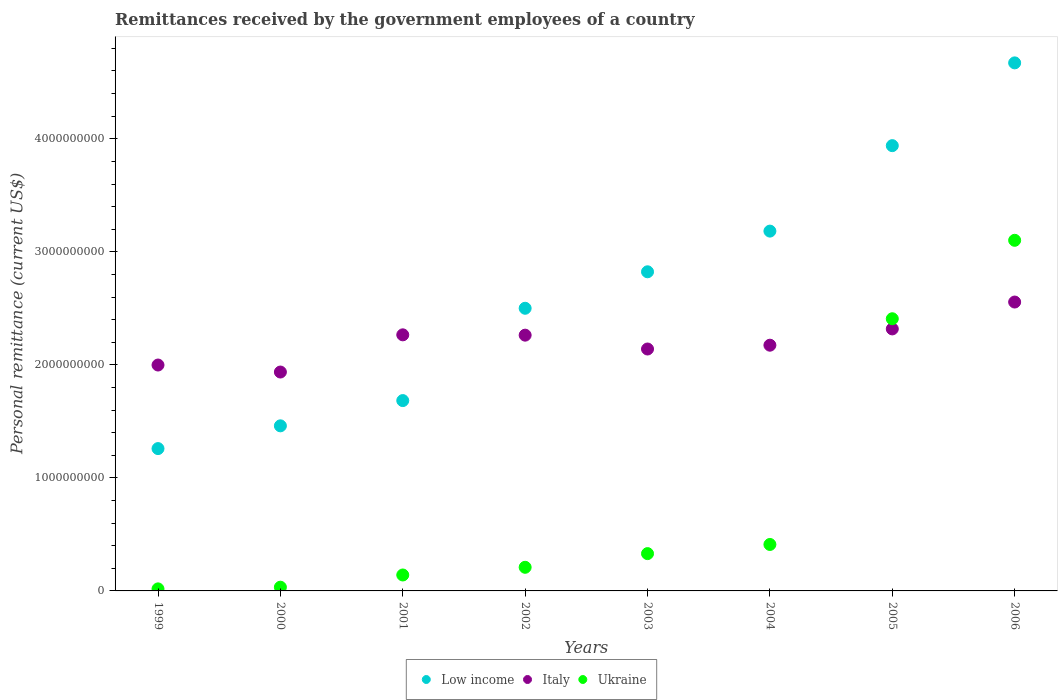How many different coloured dotlines are there?
Provide a short and direct response. 3. What is the remittances received by the government employees in Ukraine in 2006?
Keep it short and to the point. 3.10e+09. Across all years, what is the maximum remittances received by the government employees in Low income?
Give a very brief answer. 4.67e+09. Across all years, what is the minimum remittances received by the government employees in Ukraine?
Make the answer very short. 1.80e+07. In which year was the remittances received by the government employees in Italy maximum?
Keep it short and to the point. 2006. In which year was the remittances received by the government employees in Low income minimum?
Keep it short and to the point. 1999. What is the total remittances received by the government employees in Low income in the graph?
Your answer should be compact. 2.15e+1. What is the difference between the remittances received by the government employees in Low income in 2000 and that in 2001?
Provide a short and direct response. -2.23e+08. What is the difference between the remittances received by the government employees in Ukraine in 2002 and the remittances received by the government employees in Italy in 2005?
Your answer should be compact. -2.11e+09. What is the average remittances received by the government employees in Low income per year?
Offer a very short reply. 2.69e+09. In the year 2004, what is the difference between the remittances received by the government employees in Italy and remittances received by the government employees in Low income?
Your response must be concise. -1.01e+09. In how many years, is the remittances received by the government employees in Low income greater than 3800000000 US$?
Provide a short and direct response. 2. What is the ratio of the remittances received by the government employees in Italy in 1999 to that in 2003?
Your answer should be compact. 0.93. Is the remittances received by the government employees in Low income in 1999 less than that in 2006?
Make the answer very short. Yes. Is the difference between the remittances received by the government employees in Italy in 1999 and 2002 greater than the difference between the remittances received by the government employees in Low income in 1999 and 2002?
Your answer should be very brief. Yes. What is the difference between the highest and the second highest remittances received by the government employees in Italy?
Your answer should be very brief. 2.38e+08. What is the difference between the highest and the lowest remittances received by the government employees in Ukraine?
Your answer should be very brief. 3.08e+09. How many dotlines are there?
Ensure brevity in your answer.  3. Are the values on the major ticks of Y-axis written in scientific E-notation?
Your answer should be very brief. No. How are the legend labels stacked?
Keep it short and to the point. Horizontal. What is the title of the graph?
Offer a very short reply. Remittances received by the government employees of a country. Does "Montenegro" appear as one of the legend labels in the graph?
Offer a terse response. No. What is the label or title of the Y-axis?
Provide a short and direct response. Personal remittance (current US$). What is the Personal remittance (current US$) in Low income in 1999?
Give a very brief answer. 1.26e+09. What is the Personal remittance (current US$) in Italy in 1999?
Ensure brevity in your answer.  2.00e+09. What is the Personal remittance (current US$) in Ukraine in 1999?
Offer a terse response. 1.80e+07. What is the Personal remittance (current US$) in Low income in 2000?
Your answer should be very brief. 1.46e+09. What is the Personal remittance (current US$) of Italy in 2000?
Ensure brevity in your answer.  1.94e+09. What is the Personal remittance (current US$) in Ukraine in 2000?
Your answer should be very brief. 3.30e+07. What is the Personal remittance (current US$) of Low income in 2001?
Offer a very short reply. 1.68e+09. What is the Personal remittance (current US$) of Italy in 2001?
Give a very brief answer. 2.27e+09. What is the Personal remittance (current US$) of Ukraine in 2001?
Give a very brief answer. 1.41e+08. What is the Personal remittance (current US$) of Low income in 2002?
Make the answer very short. 2.50e+09. What is the Personal remittance (current US$) in Italy in 2002?
Ensure brevity in your answer.  2.26e+09. What is the Personal remittance (current US$) of Ukraine in 2002?
Keep it short and to the point. 2.09e+08. What is the Personal remittance (current US$) in Low income in 2003?
Your answer should be compact. 2.82e+09. What is the Personal remittance (current US$) in Italy in 2003?
Provide a succinct answer. 2.14e+09. What is the Personal remittance (current US$) in Ukraine in 2003?
Keep it short and to the point. 3.30e+08. What is the Personal remittance (current US$) in Low income in 2004?
Offer a very short reply. 3.18e+09. What is the Personal remittance (current US$) of Italy in 2004?
Your answer should be compact. 2.17e+09. What is the Personal remittance (current US$) of Ukraine in 2004?
Provide a short and direct response. 4.11e+08. What is the Personal remittance (current US$) of Low income in 2005?
Your answer should be very brief. 3.94e+09. What is the Personal remittance (current US$) of Italy in 2005?
Your response must be concise. 2.32e+09. What is the Personal remittance (current US$) of Ukraine in 2005?
Ensure brevity in your answer.  2.41e+09. What is the Personal remittance (current US$) of Low income in 2006?
Make the answer very short. 4.67e+09. What is the Personal remittance (current US$) of Italy in 2006?
Give a very brief answer. 2.56e+09. What is the Personal remittance (current US$) in Ukraine in 2006?
Your answer should be compact. 3.10e+09. Across all years, what is the maximum Personal remittance (current US$) in Low income?
Offer a very short reply. 4.67e+09. Across all years, what is the maximum Personal remittance (current US$) of Italy?
Make the answer very short. 2.56e+09. Across all years, what is the maximum Personal remittance (current US$) of Ukraine?
Ensure brevity in your answer.  3.10e+09. Across all years, what is the minimum Personal remittance (current US$) of Low income?
Offer a very short reply. 1.26e+09. Across all years, what is the minimum Personal remittance (current US$) in Italy?
Keep it short and to the point. 1.94e+09. Across all years, what is the minimum Personal remittance (current US$) of Ukraine?
Ensure brevity in your answer.  1.80e+07. What is the total Personal remittance (current US$) in Low income in the graph?
Keep it short and to the point. 2.15e+1. What is the total Personal remittance (current US$) in Italy in the graph?
Your response must be concise. 1.77e+1. What is the total Personal remittance (current US$) of Ukraine in the graph?
Your response must be concise. 6.65e+09. What is the difference between the Personal remittance (current US$) of Low income in 1999 and that in 2000?
Your response must be concise. -2.01e+08. What is the difference between the Personal remittance (current US$) in Italy in 1999 and that in 2000?
Ensure brevity in your answer.  6.20e+07. What is the difference between the Personal remittance (current US$) of Ukraine in 1999 and that in 2000?
Your response must be concise. -1.50e+07. What is the difference between the Personal remittance (current US$) in Low income in 1999 and that in 2001?
Provide a succinct answer. -4.25e+08. What is the difference between the Personal remittance (current US$) of Italy in 1999 and that in 2001?
Offer a terse response. -2.67e+08. What is the difference between the Personal remittance (current US$) in Ukraine in 1999 and that in 2001?
Your response must be concise. -1.23e+08. What is the difference between the Personal remittance (current US$) in Low income in 1999 and that in 2002?
Offer a terse response. -1.24e+09. What is the difference between the Personal remittance (current US$) in Italy in 1999 and that in 2002?
Make the answer very short. -2.64e+08. What is the difference between the Personal remittance (current US$) in Ukraine in 1999 and that in 2002?
Your answer should be very brief. -1.91e+08. What is the difference between the Personal remittance (current US$) in Low income in 1999 and that in 2003?
Offer a very short reply. -1.56e+09. What is the difference between the Personal remittance (current US$) in Italy in 1999 and that in 2003?
Your answer should be compact. -1.42e+08. What is the difference between the Personal remittance (current US$) in Ukraine in 1999 and that in 2003?
Offer a terse response. -3.12e+08. What is the difference between the Personal remittance (current US$) of Low income in 1999 and that in 2004?
Your answer should be compact. -1.92e+09. What is the difference between the Personal remittance (current US$) of Italy in 1999 and that in 2004?
Keep it short and to the point. -1.75e+08. What is the difference between the Personal remittance (current US$) of Ukraine in 1999 and that in 2004?
Provide a short and direct response. -3.93e+08. What is the difference between the Personal remittance (current US$) in Low income in 1999 and that in 2005?
Keep it short and to the point. -2.68e+09. What is the difference between the Personal remittance (current US$) in Italy in 1999 and that in 2005?
Make the answer very short. -3.20e+08. What is the difference between the Personal remittance (current US$) of Ukraine in 1999 and that in 2005?
Provide a short and direct response. -2.39e+09. What is the difference between the Personal remittance (current US$) of Low income in 1999 and that in 2006?
Ensure brevity in your answer.  -3.41e+09. What is the difference between the Personal remittance (current US$) in Italy in 1999 and that in 2006?
Provide a short and direct response. -5.57e+08. What is the difference between the Personal remittance (current US$) of Ukraine in 1999 and that in 2006?
Provide a short and direct response. -3.08e+09. What is the difference between the Personal remittance (current US$) of Low income in 2000 and that in 2001?
Your answer should be very brief. -2.23e+08. What is the difference between the Personal remittance (current US$) in Italy in 2000 and that in 2001?
Your response must be concise. -3.29e+08. What is the difference between the Personal remittance (current US$) in Ukraine in 2000 and that in 2001?
Offer a terse response. -1.08e+08. What is the difference between the Personal remittance (current US$) of Low income in 2000 and that in 2002?
Your response must be concise. -1.04e+09. What is the difference between the Personal remittance (current US$) in Italy in 2000 and that in 2002?
Your response must be concise. -3.26e+08. What is the difference between the Personal remittance (current US$) of Ukraine in 2000 and that in 2002?
Provide a short and direct response. -1.76e+08. What is the difference between the Personal remittance (current US$) in Low income in 2000 and that in 2003?
Keep it short and to the point. -1.36e+09. What is the difference between the Personal remittance (current US$) of Italy in 2000 and that in 2003?
Make the answer very short. -2.04e+08. What is the difference between the Personal remittance (current US$) of Ukraine in 2000 and that in 2003?
Keep it short and to the point. -2.97e+08. What is the difference between the Personal remittance (current US$) in Low income in 2000 and that in 2004?
Offer a terse response. -1.72e+09. What is the difference between the Personal remittance (current US$) of Italy in 2000 and that in 2004?
Your answer should be compact. -2.37e+08. What is the difference between the Personal remittance (current US$) in Ukraine in 2000 and that in 2004?
Keep it short and to the point. -3.78e+08. What is the difference between the Personal remittance (current US$) in Low income in 2000 and that in 2005?
Ensure brevity in your answer.  -2.48e+09. What is the difference between the Personal remittance (current US$) of Italy in 2000 and that in 2005?
Your response must be concise. -3.82e+08. What is the difference between the Personal remittance (current US$) in Ukraine in 2000 and that in 2005?
Your answer should be compact. -2.38e+09. What is the difference between the Personal remittance (current US$) of Low income in 2000 and that in 2006?
Keep it short and to the point. -3.21e+09. What is the difference between the Personal remittance (current US$) in Italy in 2000 and that in 2006?
Make the answer very short. -6.19e+08. What is the difference between the Personal remittance (current US$) of Ukraine in 2000 and that in 2006?
Offer a terse response. -3.07e+09. What is the difference between the Personal remittance (current US$) of Low income in 2001 and that in 2002?
Provide a succinct answer. -8.17e+08. What is the difference between the Personal remittance (current US$) in Italy in 2001 and that in 2002?
Give a very brief answer. 2.88e+06. What is the difference between the Personal remittance (current US$) of Ukraine in 2001 and that in 2002?
Your answer should be compact. -6.80e+07. What is the difference between the Personal remittance (current US$) in Low income in 2001 and that in 2003?
Offer a terse response. -1.14e+09. What is the difference between the Personal remittance (current US$) in Italy in 2001 and that in 2003?
Give a very brief answer. 1.25e+08. What is the difference between the Personal remittance (current US$) of Ukraine in 2001 and that in 2003?
Ensure brevity in your answer.  -1.89e+08. What is the difference between the Personal remittance (current US$) in Low income in 2001 and that in 2004?
Your answer should be compact. -1.50e+09. What is the difference between the Personal remittance (current US$) in Italy in 2001 and that in 2004?
Your response must be concise. 9.17e+07. What is the difference between the Personal remittance (current US$) of Ukraine in 2001 and that in 2004?
Give a very brief answer. -2.70e+08. What is the difference between the Personal remittance (current US$) in Low income in 2001 and that in 2005?
Make the answer very short. -2.26e+09. What is the difference between the Personal remittance (current US$) of Italy in 2001 and that in 2005?
Your answer should be compact. -5.24e+07. What is the difference between the Personal remittance (current US$) in Ukraine in 2001 and that in 2005?
Offer a very short reply. -2.27e+09. What is the difference between the Personal remittance (current US$) of Low income in 2001 and that in 2006?
Ensure brevity in your answer.  -2.99e+09. What is the difference between the Personal remittance (current US$) of Italy in 2001 and that in 2006?
Your response must be concise. -2.90e+08. What is the difference between the Personal remittance (current US$) of Ukraine in 2001 and that in 2006?
Your answer should be compact. -2.96e+09. What is the difference between the Personal remittance (current US$) of Low income in 2002 and that in 2003?
Offer a very short reply. -3.23e+08. What is the difference between the Personal remittance (current US$) in Italy in 2002 and that in 2003?
Your response must be concise. 1.23e+08. What is the difference between the Personal remittance (current US$) in Ukraine in 2002 and that in 2003?
Your answer should be very brief. -1.21e+08. What is the difference between the Personal remittance (current US$) in Low income in 2002 and that in 2004?
Offer a very short reply. -6.83e+08. What is the difference between the Personal remittance (current US$) in Italy in 2002 and that in 2004?
Make the answer very short. 8.88e+07. What is the difference between the Personal remittance (current US$) in Ukraine in 2002 and that in 2004?
Make the answer very short. -2.02e+08. What is the difference between the Personal remittance (current US$) of Low income in 2002 and that in 2005?
Your answer should be compact. -1.44e+09. What is the difference between the Personal remittance (current US$) of Italy in 2002 and that in 2005?
Ensure brevity in your answer.  -5.53e+07. What is the difference between the Personal remittance (current US$) of Ukraine in 2002 and that in 2005?
Keep it short and to the point. -2.20e+09. What is the difference between the Personal remittance (current US$) in Low income in 2002 and that in 2006?
Your answer should be compact. -2.17e+09. What is the difference between the Personal remittance (current US$) of Italy in 2002 and that in 2006?
Make the answer very short. -2.93e+08. What is the difference between the Personal remittance (current US$) of Ukraine in 2002 and that in 2006?
Your answer should be very brief. -2.89e+09. What is the difference between the Personal remittance (current US$) in Low income in 2003 and that in 2004?
Make the answer very short. -3.60e+08. What is the difference between the Personal remittance (current US$) in Italy in 2003 and that in 2004?
Your answer should be compact. -3.37e+07. What is the difference between the Personal remittance (current US$) of Ukraine in 2003 and that in 2004?
Ensure brevity in your answer.  -8.10e+07. What is the difference between the Personal remittance (current US$) of Low income in 2003 and that in 2005?
Provide a short and direct response. -1.12e+09. What is the difference between the Personal remittance (current US$) in Italy in 2003 and that in 2005?
Your answer should be compact. -1.78e+08. What is the difference between the Personal remittance (current US$) of Ukraine in 2003 and that in 2005?
Your response must be concise. -2.08e+09. What is the difference between the Personal remittance (current US$) in Low income in 2003 and that in 2006?
Ensure brevity in your answer.  -1.85e+09. What is the difference between the Personal remittance (current US$) of Italy in 2003 and that in 2006?
Keep it short and to the point. -4.16e+08. What is the difference between the Personal remittance (current US$) in Ukraine in 2003 and that in 2006?
Your answer should be compact. -2.77e+09. What is the difference between the Personal remittance (current US$) in Low income in 2004 and that in 2005?
Ensure brevity in your answer.  -7.56e+08. What is the difference between the Personal remittance (current US$) of Italy in 2004 and that in 2005?
Ensure brevity in your answer.  -1.44e+08. What is the difference between the Personal remittance (current US$) in Ukraine in 2004 and that in 2005?
Offer a very short reply. -2.00e+09. What is the difference between the Personal remittance (current US$) of Low income in 2004 and that in 2006?
Your response must be concise. -1.49e+09. What is the difference between the Personal remittance (current US$) in Italy in 2004 and that in 2006?
Provide a short and direct response. -3.82e+08. What is the difference between the Personal remittance (current US$) of Ukraine in 2004 and that in 2006?
Your response must be concise. -2.69e+09. What is the difference between the Personal remittance (current US$) in Low income in 2005 and that in 2006?
Offer a very short reply. -7.32e+08. What is the difference between the Personal remittance (current US$) of Italy in 2005 and that in 2006?
Your answer should be very brief. -2.38e+08. What is the difference between the Personal remittance (current US$) of Ukraine in 2005 and that in 2006?
Provide a succinct answer. -6.94e+08. What is the difference between the Personal remittance (current US$) in Low income in 1999 and the Personal remittance (current US$) in Italy in 2000?
Provide a short and direct response. -6.77e+08. What is the difference between the Personal remittance (current US$) in Low income in 1999 and the Personal remittance (current US$) in Ukraine in 2000?
Offer a very short reply. 1.23e+09. What is the difference between the Personal remittance (current US$) of Italy in 1999 and the Personal remittance (current US$) of Ukraine in 2000?
Your response must be concise. 1.97e+09. What is the difference between the Personal remittance (current US$) in Low income in 1999 and the Personal remittance (current US$) in Italy in 2001?
Your answer should be compact. -1.01e+09. What is the difference between the Personal remittance (current US$) of Low income in 1999 and the Personal remittance (current US$) of Ukraine in 2001?
Offer a terse response. 1.12e+09. What is the difference between the Personal remittance (current US$) in Italy in 1999 and the Personal remittance (current US$) in Ukraine in 2001?
Your answer should be very brief. 1.86e+09. What is the difference between the Personal remittance (current US$) of Low income in 1999 and the Personal remittance (current US$) of Italy in 2002?
Keep it short and to the point. -1.00e+09. What is the difference between the Personal remittance (current US$) in Low income in 1999 and the Personal remittance (current US$) in Ukraine in 2002?
Your answer should be compact. 1.05e+09. What is the difference between the Personal remittance (current US$) in Italy in 1999 and the Personal remittance (current US$) in Ukraine in 2002?
Give a very brief answer. 1.79e+09. What is the difference between the Personal remittance (current US$) of Low income in 1999 and the Personal remittance (current US$) of Italy in 2003?
Your response must be concise. -8.81e+08. What is the difference between the Personal remittance (current US$) in Low income in 1999 and the Personal remittance (current US$) in Ukraine in 2003?
Keep it short and to the point. 9.29e+08. What is the difference between the Personal remittance (current US$) of Italy in 1999 and the Personal remittance (current US$) of Ukraine in 2003?
Offer a terse response. 1.67e+09. What is the difference between the Personal remittance (current US$) in Low income in 1999 and the Personal remittance (current US$) in Italy in 2004?
Give a very brief answer. -9.15e+08. What is the difference between the Personal remittance (current US$) of Low income in 1999 and the Personal remittance (current US$) of Ukraine in 2004?
Your answer should be compact. 8.48e+08. What is the difference between the Personal remittance (current US$) in Italy in 1999 and the Personal remittance (current US$) in Ukraine in 2004?
Your answer should be very brief. 1.59e+09. What is the difference between the Personal remittance (current US$) of Low income in 1999 and the Personal remittance (current US$) of Italy in 2005?
Offer a terse response. -1.06e+09. What is the difference between the Personal remittance (current US$) in Low income in 1999 and the Personal remittance (current US$) in Ukraine in 2005?
Your response must be concise. -1.15e+09. What is the difference between the Personal remittance (current US$) in Italy in 1999 and the Personal remittance (current US$) in Ukraine in 2005?
Make the answer very short. -4.09e+08. What is the difference between the Personal remittance (current US$) of Low income in 1999 and the Personal remittance (current US$) of Italy in 2006?
Keep it short and to the point. -1.30e+09. What is the difference between the Personal remittance (current US$) of Low income in 1999 and the Personal remittance (current US$) of Ukraine in 2006?
Make the answer very short. -1.84e+09. What is the difference between the Personal remittance (current US$) of Italy in 1999 and the Personal remittance (current US$) of Ukraine in 2006?
Your response must be concise. -1.10e+09. What is the difference between the Personal remittance (current US$) in Low income in 2000 and the Personal remittance (current US$) in Italy in 2001?
Provide a short and direct response. -8.05e+08. What is the difference between the Personal remittance (current US$) of Low income in 2000 and the Personal remittance (current US$) of Ukraine in 2001?
Make the answer very short. 1.32e+09. What is the difference between the Personal remittance (current US$) in Italy in 2000 and the Personal remittance (current US$) in Ukraine in 2001?
Your answer should be very brief. 1.80e+09. What is the difference between the Personal remittance (current US$) of Low income in 2000 and the Personal remittance (current US$) of Italy in 2002?
Offer a terse response. -8.02e+08. What is the difference between the Personal remittance (current US$) of Low income in 2000 and the Personal remittance (current US$) of Ukraine in 2002?
Your answer should be very brief. 1.25e+09. What is the difference between the Personal remittance (current US$) of Italy in 2000 and the Personal remittance (current US$) of Ukraine in 2002?
Provide a short and direct response. 1.73e+09. What is the difference between the Personal remittance (current US$) in Low income in 2000 and the Personal remittance (current US$) in Italy in 2003?
Offer a very short reply. -6.80e+08. What is the difference between the Personal remittance (current US$) of Low income in 2000 and the Personal remittance (current US$) of Ukraine in 2003?
Your answer should be compact. 1.13e+09. What is the difference between the Personal remittance (current US$) of Italy in 2000 and the Personal remittance (current US$) of Ukraine in 2003?
Provide a short and direct response. 1.61e+09. What is the difference between the Personal remittance (current US$) in Low income in 2000 and the Personal remittance (current US$) in Italy in 2004?
Offer a terse response. -7.13e+08. What is the difference between the Personal remittance (current US$) in Low income in 2000 and the Personal remittance (current US$) in Ukraine in 2004?
Your answer should be compact. 1.05e+09. What is the difference between the Personal remittance (current US$) in Italy in 2000 and the Personal remittance (current US$) in Ukraine in 2004?
Your answer should be compact. 1.53e+09. What is the difference between the Personal remittance (current US$) in Low income in 2000 and the Personal remittance (current US$) in Italy in 2005?
Your answer should be compact. -8.58e+08. What is the difference between the Personal remittance (current US$) in Low income in 2000 and the Personal remittance (current US$) in Ukraine in 2005?
Offer a terse response. -9.47e+08. What is the difference between the Personal remittance (current US$) of Italy in 2000 and the Personal remittance (current US$) of Ukraine in 2005?
Ensure brevity in your answer.  -4.71e+08. What is the difference between the Personal remittance (current US$) in Low income in 2000 and the Personal remittance (current US$) in Italy in 2006?
Offer a terse response. -1.10e+09. What is the difference between the Personal remittance (current US$) of Low income in 2000 and the Personal remittance (current US$) of Ukraine in 2006?
Your answer should be compact. -1.64e+09. What is the difference between the Personal remittance (current US$) in Italy in 2000 and the Personal remittance (current US$) in Ukraine in 2006?
Make the answer very short. -1.17e+09. What is the difference between the Personal remittance (current US$) in Low income in 2001 and the Personal remittance (current US$) in Italy in 2002?
Provide a succinct answer. -5.79e+08. What is the difference between the Personal remittance (current US$) in Low income in 2001 and the Personal remittance (current US$) in Ukraine in 2002?
Your answer should be compact. 1.47e+09. What is the difference between the Personal remittance (current US$) in Italy in 2001 and the Personal remittance (current US$) in Ukraine in 2002?
Make the answer very short. 2.06e+09. What is the difference between the Personal remittance (current US$) of Low income in 2001 and the Personal remittance (current US$) of Italy in 2003?
Offer a terse response. -4.56e+08. What is the difference between the Personal remittance (current US$) in Low income in 2001 and the Personal remittance (current US$) in Ukraine in 2003?
Offer a terse response. 1.35e+09. What is the difference between the Personal remittance (current US$) in Italy in 2001 and the Personal remittance (current US$) in Ukraine in 2003?
Provide a succinct answer. 1.94e+09. What is the difference between the Personal remittance (current US$) of Low income in 2001 and the Personal remittance (current US$) of Italy in 2004?
Ensure brevity in your answer.  -4.90e+08. What is the difference between the Personal remittance (current US$) in Low income in 2001 and the Personal remittance (current US$) in Ukraine in 2004?
Make the answer very short. 1.27e+09. What is the difference between the Personal remittance (current US$) in Italy in 2001 and the Personal remittance (current US$) in Ukraine in 2004?
Your answer should be very brief. 1.85e+09. What is the difference between the Personal remittance (current US$) in Low income in 2001 and the Personal remittance (current US$) in Italy in 2005?
Offer a terse response. -6.34e+08. What is the difference between the Personal remittance (current US$) in Low income in 2001 and the Personal remittance (current US$) in Ukraine in 2005?
Make the answer very short. -7.24e+08. What is the difference between the Personal remittance (current US$) of Italy in 2001 and the Personal remittance (current US$) of Ukraine in 2005?
Provide a short and direct response. -1.42e+08. What is the difference between the Personal remittance (current US$) of Low income in 2001 and the Personal remittance (current US$) of Italy in 2006?
Provide a succinct answer. -8.72e+08. What is the difference between the Personal remittance (current US$) in Low income in 2001 and the Personal remittance (current US$) in Ukraine in 2006?
Keep it short and to the point. -1.42e+09. What is the difference between the Personal remittance (current US$) in Italy in 2001 and the Personal remittance (current US$) in Ukraine in 2006?
Offer a terse response. -8.36e+08. What is the difference between the Personal remittance (current US$) of Low income in 2002 and the Personal remittance (current US$) of Italy in 2003?
Your response must be concise. 3.60e+08. What is the difference between the Personal remittance (current US$) in Low income in 2002 and the Personal remittance (current US$) in Ukraine in 2003?
Provide a succinct answer. 2.17e+09. What is the difference between the Personal remittance (current US$) in Italy in 2002 and the Personal remittance (current US$) in Ukraine in 2003?
Provide a succinct answer. 1.93e+09. What is the difference between the Personal remittance (current US$) in Low income in 2002 and the Personal remittance (current US$) in Italy in 2004?
Your answer should be compact. 3.27e+08. What is the difference between the Personal remittance (current US$) of Low income in 2002 and the Personal remittance (current US$) of Ukraine in 2004?
Your response must be concise. 2.09e+09. What is the difference between the Personal remittance (current US$) of Italy in 2002 and the Personal remittance (current US$) of Ukraine in 2004?
Keep it short and to the point. 1.85e+09. What is the difference between the Personal remittance (current US$) in Low income in 2002 and the Personal remittance (current US$) in Italy in 2005?
Your response must be concise. 1.83e+08. What is the difference between the Personal remittance (current US$) in Low income in 2002 and the Personal remittance (current US$) in Ukraine in 2005?
Ensure brevity in your answer.  9.27e+07. What is the difference between the Personal remittance (current US$) in Italy in 2002 and the Personal remittance (current US$) in Ukraine in 2005?
Your answer should be compact. -1.45e+08. What is the difference between the Personal remittance (current US$) in Low income in 2002 and the Personal remittance (current US$) in Italy in 2006?
Make the answer very short. -5.51e+07. What is the difference between the Personal remittance (current US$) in Low income in 2002 and the Personal remittance (current US$) in Ukraine in 2006?
Offer a very short reply. -6.01e+08. What is the difference between the Personal remittance (current US$) of Italy in 2002 and the Personal remittance (current US$) of Ukraine in 2006?
Your answer should be very brief. -8.39e+08. What is the difference between the Personal remittance (current US$) of Low income in 2003 and the Personal remittance (current US$) of Italy in 2004?
Provide a short and direct response. 6.49e+08. What is the difference between the Personal remittance (current US$) of Low income in 2003 and the Personal remittance (current US$) of Ukraine in 2004?
Give a very brief answer. 2.41e+09. What is the difference between the Personal remittance (current US$) of Italy in 2003 and the Personal remittance (current US$) of Ukraine in 2004?
Offer a very short reply. 1.73e+09. What is the difference between the Personal remittance (current US$) in Low income in 2003 and the Personal remittance (current US$) in Italy in 2005?
Provide a short and direct response. 5.05e+08. What is the difference between the Personal remittance (current US$) of Low income in 2003 and the Personal remittance (current US$) of Ukraine in 2005?
Your answer should be compact. 4.15e+08. What is the difference between the Personal remittance (current US$) in Italy in 2003 and the Personal remittance (current US$) in Ukraine in 2005?
Offer a very short reply. -2.68e+08. What is the difference between the Personal remittance (current US$) in Low income in 2003 and the Personal remittance (current US$) in Italy in 2006?
Ensure brevity in your answer.  2.68e+08. What is the difference between the Personal remittance (current US$) of Low income in 2003 and the Personal remittance (current US$) of Ukraine in 2006?
Your response must be concise. -2.79e+08. What is the difference between the Personal remittance (current US$) of Italy in 2003 and the Personal remittance (current US$) of Ukraine in 2006?
Provide a succinct answer. -9.62e+08. What is the difference between the Personal remittance (current US$) in Low income in 2004 and the Personal remittance (current US$) in Italy in 2005?
Your response must be concise. 8.65e+08. What is the difference between the Personal remittance (current US$) of Low income in 2004 and the Personal remittance (current US$) of Ukraine in 2005?
Your answer should be very brief. 7.75e+08. What is the difference between the Personal remittance (current US$) of Italy in 2004 and the Personal remittance (current US$) of Ukraine in 2005?
Your answer should be very brief. -2.34e+08. What is the difference between the Personal remittance (current US$) of Low income in 2004 and the Personal remittance (current US$) of Italy in 2006?
Ensure brevity in your answer.  6.28e+08. What is the difference between the Personal remittance (current US$) of Low income in 2004 and the Personal remittance (current US$) of Ukraine in 2006?
Offer a very short reply. 8.14e+07. What is the difference between the Personal remittance (current US$) in Italy in 2004 and the Personal remittance (current US$) in Ukraine in 2006?
Keep it short and to the point. -9.28e+08. What is the difference between the Personal remittance (current US$) of Low income in 2005 and the Personal remittance (current US$) of Italy in 2006?
Your answer should be compact. 1.38e+09. What is the difference between the Personal remittance (current US$) of Low income in 2005 and the Personal remittance (current US$) of Ukraine in 2006?
Your response must be concise. 8.37e+08. What is the difference between the Personal remittance (current US$) in Italy in 2005 and the Personal remittance (current US$) in Ukraine in 2006?
Give a very brief answer. -7.84e+08. What is the average Personal remittance (current US$) of Low income per year?
Your answer should be very brief. 2.69e+09. What is the average Personal remittance (current US$) in Italy per year?
Keep it short and to the point. 2.21e+09. What is the average Personal remittance (current US$) of Ukraine per year?
Give a very brief answer. 8.32e+08. In the year 1999, what is the difference between the Personal remittance (current US$) in Low income and Personal remittance (current US$) in Italy?
Ensure brevity in your answer.  -7.39e+08. In the year 1999, what is the difference between the Personal remittance (current US$) in Low income and Personal remittance (current US$) in Ukraine?
Offer a very short reply. 1.24e+09. In the year 1999, what is the difference between the Personal remittance (current US$) in Italy and Personal remittance (current US$) in Ukraine?
Provide a short and direct response. 1.98e+09. In the year 2000, what is the difference between the Personal remittance (current US$) in Low income and Personal remittance (current US$) in Italy?
Your answer should be compact. -4.76e+08. In the year 2000, what is the difference between the Personal remittance (current US$) of Low income and Personal remittance (current US$) of Ukraine?
Your answer should be compact. 1.43e+09. In the year 2000, what is the difference between the Personal remittance (current US$) in Italy and Personal remittance (current US$) in Ukraine?
Provide a short and direct response. 1.90e+09. In the year 2001, what is the difference between the Personal remittance (current US$) of Low income and Personal remittance (current US$) of Italy?
Provide a short and direct response. -5.82e+08. In the year 2001, what is the difference between the Personal remittance (current US$) of Low income and Personal remittance (current US$) of Ukraine?
Your response must be concise. 1.54e+09. In the year 2001, what is the difference between the Personal remittance (current US$) in Italy and Personal remittance (current US$) in Ukraine?
Your answer should be very brief. 2.12e+09. In the year 2002, what is the difference between the Personal remittance (current US$) of Low income and Personal remittance (current US$) of Italy?
Ensure brevity in your answer.  2.38e+08. In the year 2002, what is the difference between the Personal remittance (current US$) in Low income and Personal remittance (current US$) in Ukraine?
Keep it short and to the point. 2.29e+09. In the year 2002, what is the difference between the Personal remittance (current US$) in Italy and Personal remittance (current US$) in Ukraine?
Give a very brief answer. 2.05e+09. In the year 2003, what is the difference between the Personal remittance (current US$) in Low income and Personal remittance (current US$) in Italy?
Your answer should be compact. 6.83e+08. In the year 2003, what is the difference between the Personal remittance (current US$) in Low income and Personal remittance (current US$) in Ukraine?
Ensure brevity in your answer.  2.49e+09. In the year 2003, what is the difference between the Personal remittance (current US$) of Italy and Personal remittance (current US$) of Ukraine?
Your answer should be compact. 1.81e+09. In the year 2004, what is the difference between the Personal remittance (current US$) of Low income and Personal remittance (current US$) of Italy?
Ensure brevity in your answer.  1.01e+09. In the year 2004, what is the difference between the Personal remittance (current US$) of Low income and Personal remittance (current US$) of Ukraine?
Offer a very short reply. 2.77e+09. In the year 2004, what is the difference between the Personal remittance (current US$) in Italy and Personal remittance (current US$) in Ukraine?
Offer a very short reply. 1.76e+09. In the year 2005, what is the difference between the Personal remittance (current US$) in Low income and Personal remittance (current US$) in Italy?
Offer a very short reply. 1.62e+09. In the year 2005, what is the difference between the Personal remittance (current US$) in Low income and Personal remittance (current US$) in Ukraine?
Provide a succinct answer. 1.53e+09. In the year 2005, what is the difference between the Personal remittance (current US$) of Italy and Personal remittance (current US$) of Ukraine?
Your answer should be very brief. -8.99e+07. In the year 2006, what is the difference between the Personal remittance (current US$) in Low income and Personal remittance (current US$) in Italy?
Offer a terse response. 2.12e+09. In the year 2006, what is the difference between the Personal remittance (current US$) in Low income and Personal remittance (current US$) in Ukraine?
Ensure brevity in your answer.  1.57e+09. In the year 2006, what is the difference between the Personal remittance (current US$) in Italy and Personal remittance (current US$) in Ukraine?
Make the answer very short. -5.46e+08. What is the ratio of the Personal remittance (current US$) in Low income in 1999 to that in 2000?
Keep it short and to the point. 0.86. What is the ratio of the Personal remittance (current US$) of Italy in 1999 to that in 2000?
Provide a short and direct response. 1.03. What is the ratio of the Personal remittance (current US$) in Ukraine in 1999 to that in 2000?
Your answer should be compact. 0.55. What is the ratio of the Personal remittance (current US$) in Low income in 1999 to that in 2001?
Your answer should be very brief. 0.75. What is the ratio of the Personal remittance (current US$) in Italy in 1999 to that in 2001?
Your answer should be compact. 0.88. What is the ratio of the Personal remittance (current US$) in Ukraine in 1999 to that in 2001?
Offer a terse response. 0.13. What is the ratio of the Personal remittance (current US$) of Low income in 1999 to that in 2002?
Provide a short and direct response. 0.5. What is the ratio of the Personal remittance (current US$) in Italy in 1999 to that in 2002?
Ensure brevity in your answer.  0.88. What is the ratio of the Personal remittance (current US$) of Ukraine in 1999 to that in 2002?
Offer a terse response. 0.09. What is the ratio of the Personal remittance (current US$) of Low income in 1999 to that in 2003?
Your answer should be compact. 0.45. What is the ratio of the Personal remittance (current US$) in Italy in 1999 to that in 2003?
Keep it short and to the point. 0.93. What is the ratio of the Personal remittance (current US$) of Ukraine in 1999 to that in 2003?
Provide a succinct answer. 0.05. What is the ratio of the Personal remittance (current US$) of Low income in 1999 to that in 2004?
Keep it short and to the point. 0.4. What is the ratio of the Personal remittance (current US$) in Italy in 1999 to that in 2004?
Your answer should be compact. 0.92. What is the ratio of the Personal remittance (current US$) of Ukraine in 1999 to that in 2004?
Offer a very short reply. 0.04. What is the ratio of the Personal remittance (current US$) in Low income in 1999 to that in 2005?
Keep it short and to the point. 0.32. What is the ratio of the Personal remittance (current US$) in Italy in 1999 to that in 2005?
Ensure brevity in your answer.  0.86. What is the ratio of the Personal remittance (current US$) in Ukraine in 1999 to that in 2005?
Your answer should be very brief. 0.01. What is the ratio of the Personal remittance (current US$) in Low income in 1999 to that in 2006?
Offer a terse response. 0.27. What is the ratio of the Personal remittance (current US$) in Italy in 1999 to that in 2006?
Make the answer very short. 0.78. What is the ratio of the Personal remittance (current US$) of Ukraine in 1999 to that in 2006?
Provide a short and direct response. 0.01. What is the ratio of the Personal remittance (current US$) of Low income in 2000 to that in 2001?
Offer a terse response. 0.87. What is the ratio of the Personal remittance (current US$) in Italy in 2000 to that in 2001?
Provide a short and direct response. 0.85. What is the ratio of the Personal remittance (current US$) in Ukraine in 2000 to that in 2001?
Provide a short and direct response. 0.23. What is the ratio of the Personal remittance (current US$) in Low income in 2000 to that in 2002?
Offer a very short reply. 0.58. What is the ratio of the Personal remittance (current US$) of Italy in 2000 to that in 2002?
Your response must be concise. 0.86. What is the ratio of the Personal remittance (current US$) in Ukraine in 2000 to that in 2002?
Offer a very short reply. 0.16. What is the ratio of the Personal remittance (current US$) of Low income in 2000 to that in 2003?
Your response must be concise. 0.52. What is the ratio of the Personal remittance (current US$) in Italy in 2000 to that in 2003?
Provide a short and direct response. 0.9. What is the ratio of the Personal remittance (current US$) in Ukraine in 2000 to that in 2003?
Offer a terse response. 0.1. What is the ratio of the Personal remittance (current US$) of Low income in 2000 to that in 2004?
Provide a succinct answer. 0.46. What is the ratio of the Personal remittance (current US$) of Italy in 2000 to that in 2004?
Provide a succinct answer. 0.89. What is the ratio of the Personal remittance (current US$) of Ukraine in 2000 to that in 2004?
Keep it short and to the point. 0.08. What is the ratio of the Personal remittance (current US$) of Low income in 2000 to that in 2005?
Offer a very short reply. 0.37. What is the ratio of the Personal remittance (current US$) in Italy in 2000 to that in 2005?
Your answer should be compact. 0.84. What is the ratio of the Personal remittance (current US$) of Ukraine in 2000 to that in 2005?
Ensure brevity in your answer.  0.01. What is the ratio of the Personal remittance (current US$) in Low income in 2000 to that in 2006?
Ensure brevity in your answer.  0.31. What is the ratio of the Personal remittance (current US$) in Italy in 2000 to that in 2006?
Give a very brief answer. 0.76. What is the ratio of the Personal remittance (current US$) in Ukraine in 2000 to that in 2006?
Keep it short and to the point. 0.01. What is the ratio of the Personal remittance (current US$) in Low income in 2001 to that in 2002?
Offer a terse response. 0.67. What is the ratio of the Personal remittance (current US$) of Italy in 2001 to that in 2002?
Give a very brief answer. 1. What is the ratio of the Personal remittance (current US$) of Ukraine in 2001 to that in 2002?
Offer a very short reply. 0.67. What is the ratio of the Personal remittance (current US$) in Low income in 2001 to that in 2003?
Your answer should be compact. 0.6. What is the ratio of the Personal remittance (current US$) in Italy in 2001 to that in 2003?
Your answer should be compact. 1.06. What is the ratio of the Personal remittance (current US$) in Ukraine in 2001 to that in 2003?
Your response must be concise. 0.43. What is the ratio of the Personal remittance (current US$) of Low income in 2001 to that in 2004?
Ensure brevity in your answer.  0.53. What is the ratio of the Personal remittance (current US$) in Italy in 2001 to that in 2004?
Keep it short and to the point. 1.04. What is the ratio of the Personal remittance (current US$) of Ukraine in 2001 to that in 2004?
Make the answer very short. 0.34. What is the ratio of the Personal remittance (current US$) in Low income in 2001 to that in 2005?
Provide a succinct answer. 0.43. What is the ratio of the Personal remittance (current US$) in Italy in 2001 to that in 2005?
Provide a short and direct response. 0.98. What is the ratio of the Personal remittance (current US$) in Ukraine in 2001 to that in 2005?
Provide a short and direct response. 0.06. What is the ratio of the Personal remittance (current US$) of Low income in 2001 to that in 2006?
Your response must be concise. 0.36. What is the ratio of the Personal remittance (current US$) in Italy in 2001 to that in 2006?
Provide a short and direct response. 0.89. What is the ratio of the Personal remittance (current US$) in Ukraine in 2001 to that in 2006?
Provide a succinct answer. 0.05. What is the ratio of the Personal remittance (current US$) of Low income in 2002 to that in 2003?
Your answer should be compact. 0.89. What is the ratio of the Personal remittance (current US$) in Italy in 2002 to that in 2003?
Ensure brevity in your answer.  1.06. What is the ratio of the Personal remittance (current US$) of Ukraine in 2002 to that in 2003?
Make the answer very short. 0.63. What is the ratio of the Personal remittance (current US$) in Low income in 2002 to that in 2004?
Provide a succinct answer. 0.79. What is the ratio of the Personal remittance (current US$) of Italy in 2002 to that in 2004?
Ensure brevity in your answer.  1.04. What is the ratio of the Personal remittance (current US$) in Ukraine in 2002 to that in 2004?
Provide a short and direct response. 0.51. What is the ratio of the Personal remittance (current US$) of Low income in 2002 to that in 2005?
Offer a very short reply. 0.63. What is the ratio of the Personal remittance (current US$) in Italy in 2002 to that in 2005?
Give a very brief answer. 0.98. What is the ratio of the Personal remittance (current US$) in Ukraine in 2002 to that in 2005?
Provide a succinct answer. 0.09. What is the ratio of the Personal remittance (current US$) of Low income in 2002 to that in 2006?
Your answer should be compact. 0.54. What is the ratio of the Personal remittance (current US$) in Italy in 2002 to that in 2006?
Offer a very short reply. 0.89. What is the ratio of the Personal remittance (current US$) in Ukraine in 2002 to that in 2006?
Offer a terse response. 0.07. What is the ratio of the Personal remittance (current US$) in Low income in 2003 to that in 2004?
Your response must be concise. 0.89. What is the ratio of the Personal remittance (current US$) in Italy in 2003 to that in 2004?
Keep it short and to the point. 0.98. What is the ratio of the Personal remittance (current US$) in Ukraine in 2003 to that in 2004?
Offer a very short reply. 0.8. What is the ratio of the Personal remittance (current US$) in Low income in 2003 to that in 2005?
Offer a terse response. 0.72. What is the ratio of the Personal remittance (current US$) of Italy in 2003 to that in 2005?
Offer a terse response. 0.92. What is the ratio of the Personal remittance (current US$) of Ukraine in 2003 to that in 2005?
Provide a short and direct response. 0.14. What is the ratio of the Personal remittance (current US$) in Low income in 2003 to that in 2006?
Give a very brief answer. 0.6. What is the ratio of the Personal remittance (current US$) of Italy in 2003 to that in 2006?
Keep it short and to the point. 0.84. What is the ratio of the Personal remittance (current US$) of Ukraine in 2003 to that in 2006?
Offer a terse response. 0.11. What is the ratio of the Personal remittance (current US$) of Low income in 2004 to that in 2005?
Give a very brief answer. 0.81. What is the ratio of the Personal remittance (current US$) of Italy in 2004 to that in 2005?
Your answer should be very brief. 0.94. What is the ratio of the Personal remittance (current US$) in Ukraine in 2004 to that in 2005?
Offer a very short reply. 0.17. What is the ratio of the Personal remittance (current US$) of Low income in 2004 to that in 2006?
Offer a terse response. 0.68. What is the ratio of the Personal remittance (current US$) in Italy in 2004 to that in 2006?
Your answer should be very brief. 0.85. What is the ratio of the Personal remittance (current US$) in Ukraine in 2004 to that in 2006?
Your answer should be very brief. 0.13. What is the ratio of the Personal remittance (current US$) of Low income in 2005 to that in 2006?
Make the answer very short. 0.84. What is the ratio of the Personal remittance (current US$) of Italy in 2005 to that in 2006?
Offer a terse response. 0.91. What is the ratio of the Personal remittance (current US$) of Ukraine in 2005 to that in 2006?
Make the answer very short. 0.78. What is the difference between the highest and the second highest Personal remittance (current US$) in Low income?
Your response must be concise. 7.32e+08. What is the difference between the highest and the second highest Personal remittance (current US$) in Italy?
Your answer should be compact. 2.38e+08. What is the difference between the highest and the second highest Personal remittance (current US$) of Ukraine?
Your response must be concise. 6.94e+08. What is the difference between the highest and the lowest Personal remittance (current US$) in Low income?
Ensure brevity in your answer.  3.41e+09. What is the difference between the highest and the lowest Personal remittance (current US$) in Italy?
Keep it short and to the point. 6.19e+08. What is the difference between the highest and the lowest Personal remittance (current US$) of Ukraine?
Offer a very short reply. 3.08e+09. 